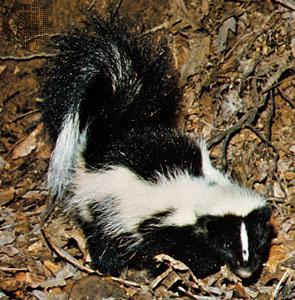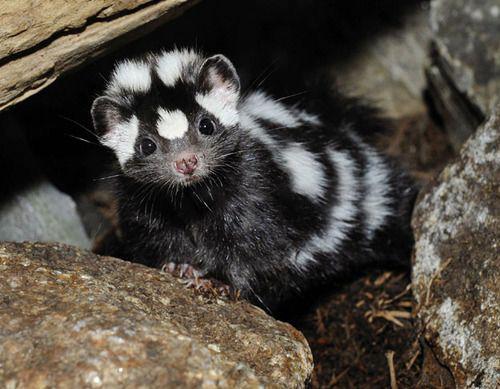The first image is the image on the left, the second image is the image on the right. For the images shown, is this caption "One image contains a spotted skunk with its face down and its tail somewhat curled, and the other image contains one skunk with bold white stripe, which is standing on all fours." true? Answer yes or no. No. 